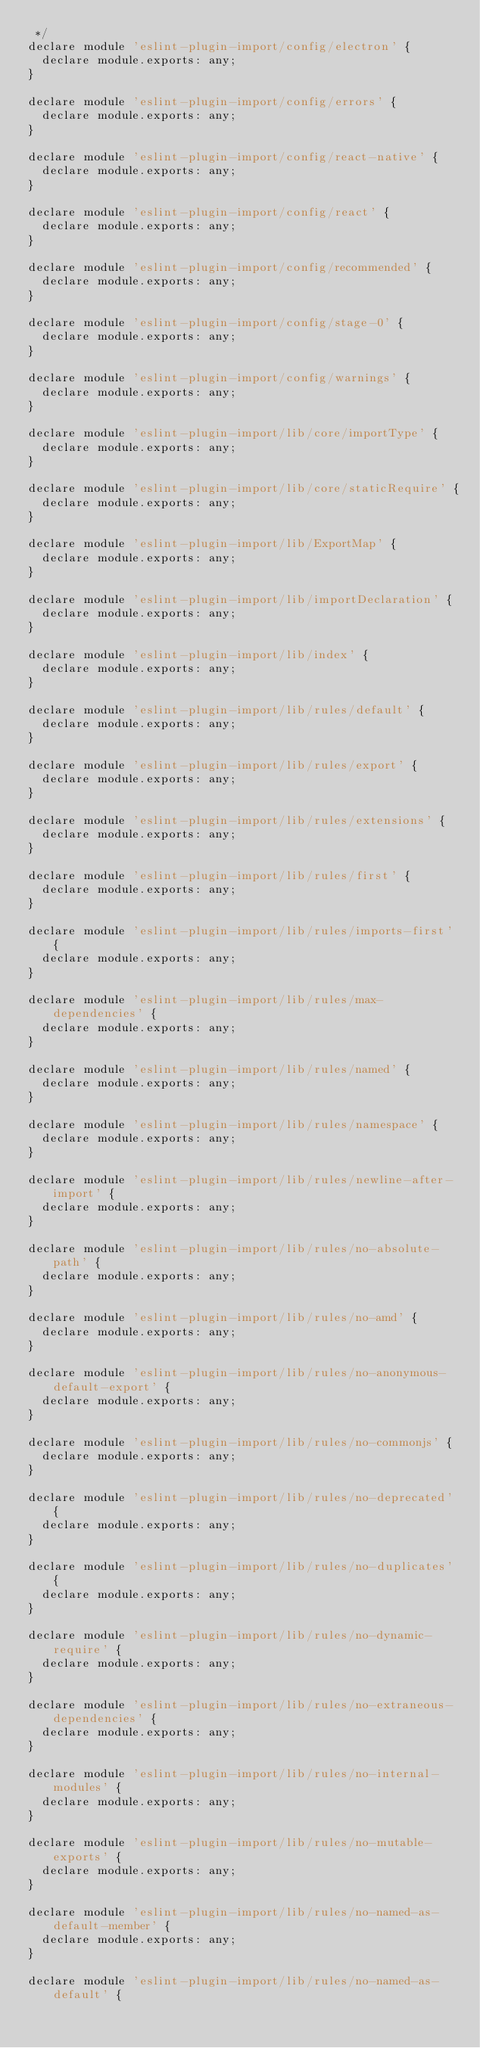<code> <loc_0><loc_0><loc_500><loc_500><_JavaScript_> */
declare module 'eslint-plugin-import/config/electron' {
  declare module.exports: any;
}

declare module 'eslint-plugin-import/config/errors' {
  declare module.exports: any;
}

declare module 'eslint-plugin-import/config/react-native' {
  declare module.exports: any;
}

declare module 'eslint-plugin-import/config/react' {
  declare module.exports: any;
}

declare module 'eslint-plugin-import/config/recommended' {
  declare module.exports: any;
}

declare module 'eslint-plugin-import/config/stage-0' {
  declare module.exports: any;
}

declare module 'eslint-plugin-import/config/warnings' {
  declare module.exports: any;
}

declare module 'eslint-plugin-import/lib/core/importType' {
  declare module.exports: any;
}

declare module 'eslint-plugin-import/lib/core/staticRequire' {
  declare module.exports: any;
}

declare module 'eslint-plugin-import/lib/ExportMap' {
  declare module.exports: any;
}

declare module 'eslint-plugin-import/lib/importDeclaration' {
  declare module.exports: any;
}

declare module 'eslint-plugin-import/lib/index' {
  declare module.exports: any;
}

declare module 'eslint-plugin-import/lib/rules/default' {
  declare module.exports: any;
}

declare module 'eslint-plugin-import/lib/rules/export' {
  declare module.exports: any;
}

declare module 'eslint-plugin-import/lib/rules/extensions' {
  declare module.exports: any;
}

declare module 'eslint-plugin-import/lib/rules/first' {
  declare module.exports: any;
}

declare module 'eslint-plugin-import/lib/rules/imports-first' {
  declare module.exports: any;
}

declare module 'eslint-plugin-import/lib/rules/max-dependencies' {
  declare module.exports: any;
}

declare module 'eslint-plugin-import/lib/rules/named' {
  declare module.exports: any;
}

declare module 'eslint-plugin-import/lib/rules/namespace' {
  declare module.exports: any;
}

declare module 'eslint-plugin-import/lib/rules/newline-after-import' {
  declare module.exports: any;
}

declare module 'eslint-plugin-import/lib/rules/no-absolute-path' {
  declare module.exports: any;
}

declare module 'eslint-plugin-import/lib/rules/no-amd' {
  declare module.exports: any;
}

declare module 'eslint-plugin-import/lib/rules/no-anonymous-default-export' {
  declare module.exports: any;
}

declare module 'eslint-plugin-import/lib/rules/no-commonjs' {
  declare module.exports: any;
}

declare module 'eslint-plugin-import/lib/rules/no-deprecated' {
  declare module.exports: any;
}

declare module 'eslint-plugin-import/lib/rules/no-duplicates' {
  declare module.exports: any;
}

declare module 'eslint-plugin-import/lib/rules/no-dynamic-require' {
  declare module.exports: any;
}

declare module 'eslint-plugin-import/lib/rules/no-extraneous-dependencies' {
  declare module.exports: any;
}

declare module 'eslint-plugin-import/lib/rules/no-internal-modules' {
  declare module.exports: any;
}

declare module 'eslint-plugin-import/lib/rules/no-mutable-exports' {
  declare module.exports: any;
}

declare module 'eslint-plugin-import/lib/rules/no-named-as-default-member' {
  declare module.exports: any;
}

declare module 'eslint-plugin-import/lib/rules/no-named-as-default' {</code> 